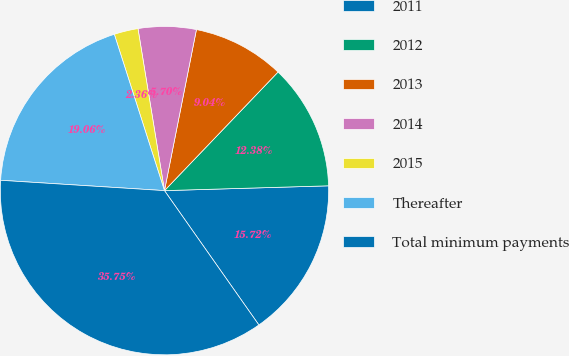Convert chart to OTSL. <chart><loc_0><loc_0><loc_500><loc_500><pie_chart><fcel>2011<fcel>2012<fcel>2013<fcel>2014<fcel>2015<fcel>Thereafter<fcel>Total minimum payments<nl><fcel>15.72%<fcel>12.38%<fcel>9.04%<fcel>5.7%<fcel>2.36%<fcel>19.06%<fcel>35.76%<nl></chart> 